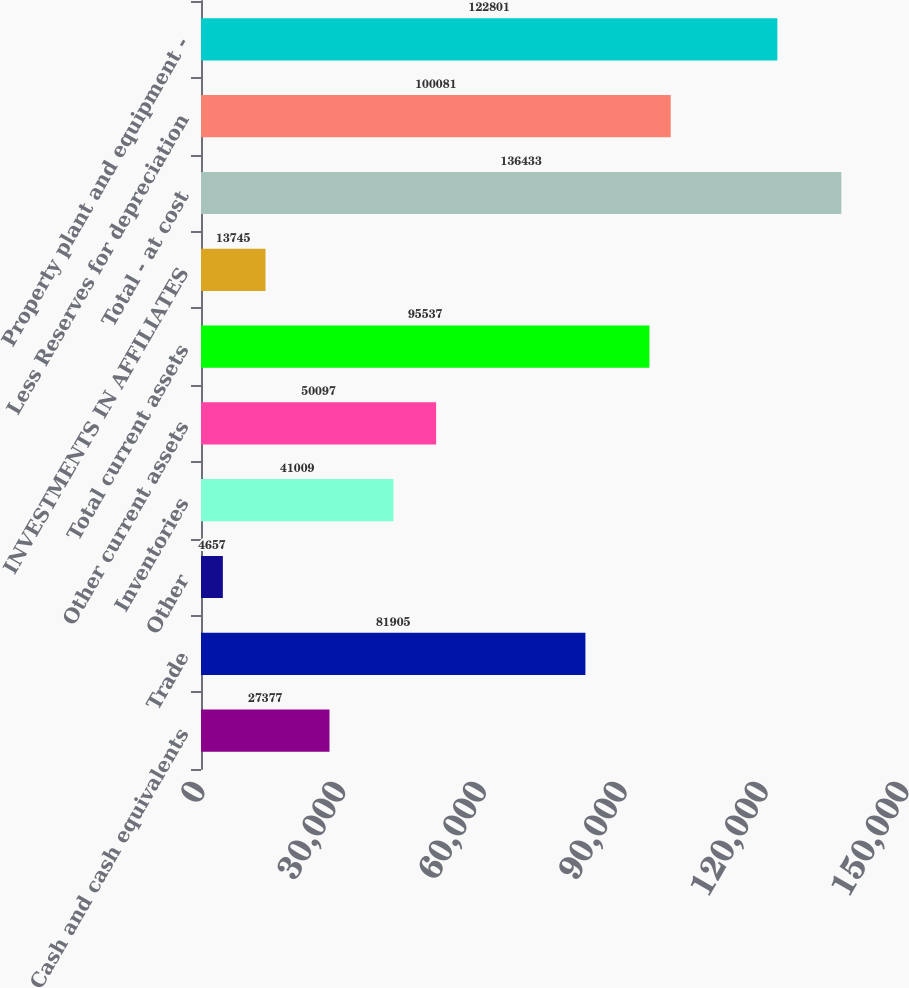Convert chart to OTSL. <chart><loc_0><loc_0><loc_500><loc_500><bar_chart><fcel>Cash and cash equivalents<fcel>Trade<fcel>Other<fcel>Inventories<fcel>Other current assets<fcel>Total current assets<fcel>INVESTMENTS IN AFFILIATES<fcel>Total - at cost<fcel>Less Reserves for depreciation<fcel>Property plant and equipment -<nl><fcel>27377<fcel>81905<fcel>4657<fcel>41009<fcel>50097<fcel>95537<fcel>13745<fcel>136433<fcel>100081<fcel>122801<nl></chart> 